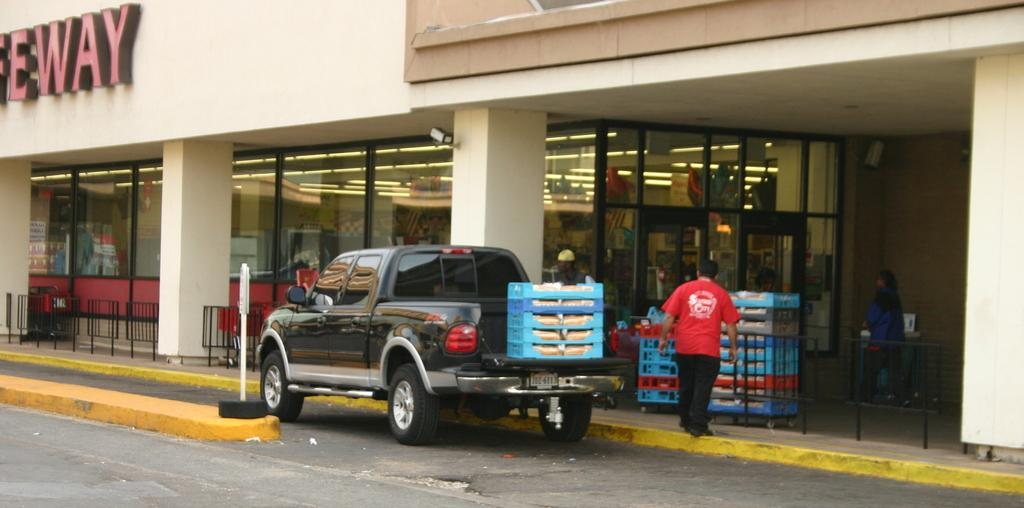What is the main subject of the image? There is a van on a road in the image. What can be seen in the background of the image? There is a shopping mall in the background of the image. What is inside the shopping mall? There are boxes visible in the shopping mall. What type of windows are present in the shopping mall? There are glass windows in the shopping mall. Where is the cemetery located in the image? There is no cemetery present in the image. On which side of the van is the shopping mall located? The image does not provide information about the side of the van in relation to the shopping mall. 